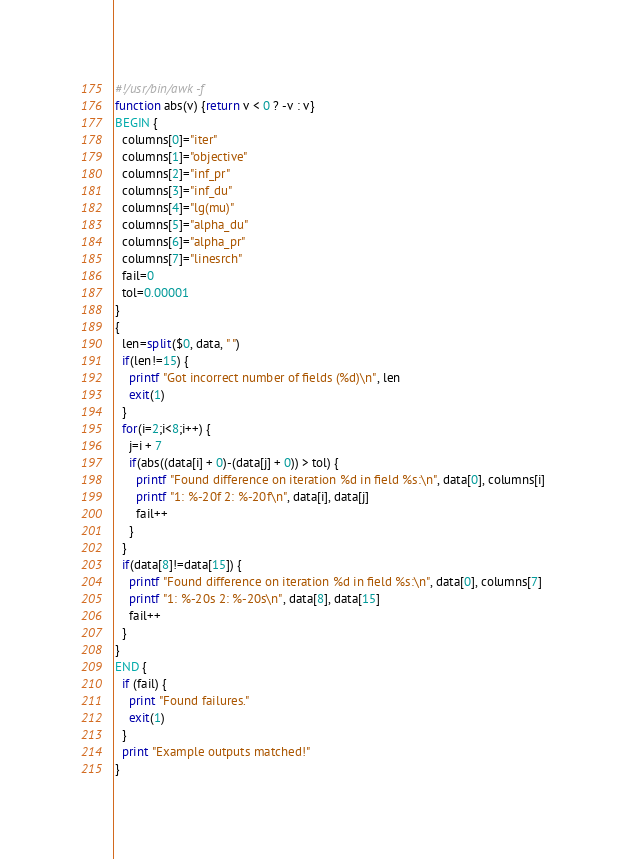<code> <loc_0><loc_0><loc_500><loc_500><_Awk_>#!/usr/bin/awk -f
function abs(v) {return v < 0 ? -v : v}
BEGIN {
  columns[0]="iter"
  columns[1]="objective"
  columns[2]="inf_pr"
  columns[3]="inf_du"
  columns[4]="lg(mu)"
  columns[5]="alpha_du"
  columns[6]="alpha_pr"
  columns[7]="linesrch"
  fail=0
  tol=0.00001
}
{
  len=split($0, data, " ")
  if(len!=15) {
    printf "Got incorrect number of fields (%d)\n", len
    exit(1)
  }
  for(i=2;i<8;i++) {
    j=i + 7
    if(abs((data[i] + 0)-(data[j] + 0)) > tol) {
      printf "Found difference on iteration %d in field %s:\n", data[0], columns[i]
      printf "1: %-20f 2: %-20f\n", data[i], data[j]
      fail++
    }
  }
  if(data[8]!=data[15]) {
    printf "Found difference on iteration %d in field %s:\n", data[0], columns[7]
    printf "1: %-20s 2: %-20s\n", data[8], data[15]
    fail++
  }
}
END {
  if (fail) {
    print "Found failures."
    exit(1)
  }
  print "Example outputs matched!"
}
</code> 